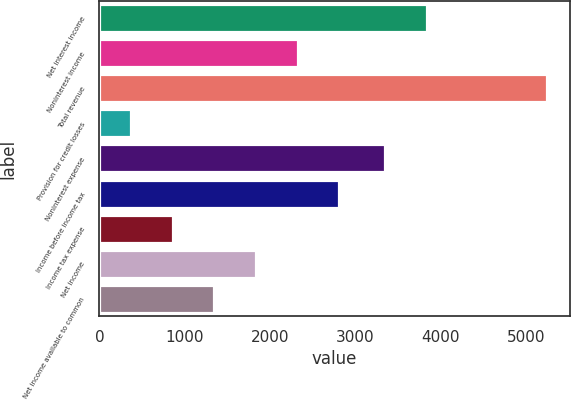Convert chart to OTSL. <chart><loc_0><loc_0><loc_500><loc_500><bar_chart><fcel>Net interest income<fcel>Noninterest income<fcel>Total revenue<fcel>Provision for credit losses<fcel>Noninterest expense<fcel>Income before income tax<fcel>Income tax expense<fcel>Net income<fcel>Net income available to common<nl><fcel>3840.6<fcel>2323.4<fcel>5255<fcel>369<fcel>3352<fcel>2812<fcel>857.6<fcel>1834.8<fcel>1346.2<nl></chart> 